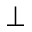Convert formula to latex. <formula><loc_0><loc_0><loc_500><loc_500>\perp</formula> 